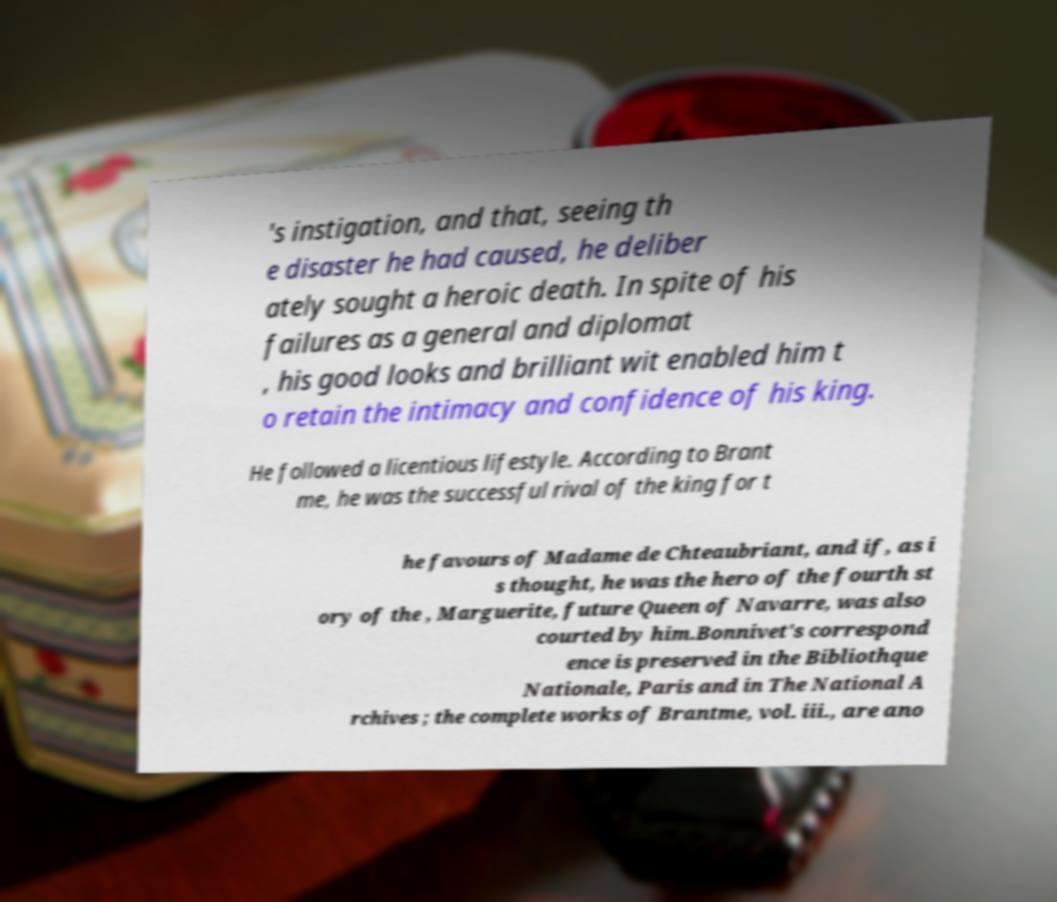Can you read and provide the text displayed in the image?This photo seems to have some interesting text. Can you extract and type it out for me? 's instigation, and that, seeing th e disaster he had caused, he deliber ately sought a heroic death. In spite of his failures as a general and diplomat , his good looks and brilliant wit enabled him t o retain the intimacy and confidence of his king. He followed a licentious lifestyle. According to Brant me, he was the successful rival of the king for t he favours of Madame de Chteaubriant, and if, as i s thought, he was the hero of the fourth st ory of the , Marguerite, future Queen of Navarre, was also courted by him.Bonnivet's correspond ence is preserved in the Bibliothque Nationale, Paris and in The National A rchives ; the complete works of Brantme, vol. iii., are ano 